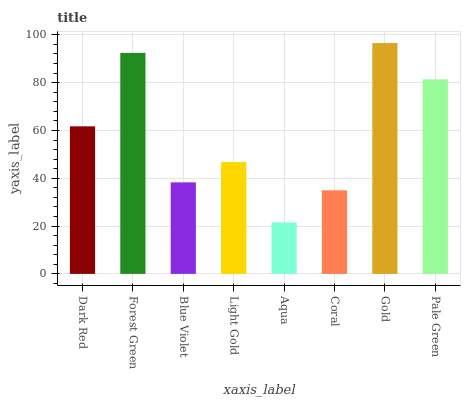Is Aqua the minimum?
Answer yes or no. Yes. Is Gold the maximum?
Answer yes or no. Yes. Is Forest Green the minimum?
Answer yes or no. No. Is Forest Green the maximum?
Answer yes or no. No. Is Forest Green greater than Dark Red?
Answer yes or no. Yes. Is Dark Red less than Forest Green?
Answer yes or no. Yes. Is Dark Red greater than Forest Green?
Answer yes or no. No. Is Forest Green less than Dark Red?
Answer yes or no. No. Is Dark Red the high median?
Answer yes or no. Yes. Is Light Gold the low median?
Answer yes or no. Yes. Is Gold the high median?
Answer yes or no. No. Is Aqua the low median?
Answer yes or no. No. 